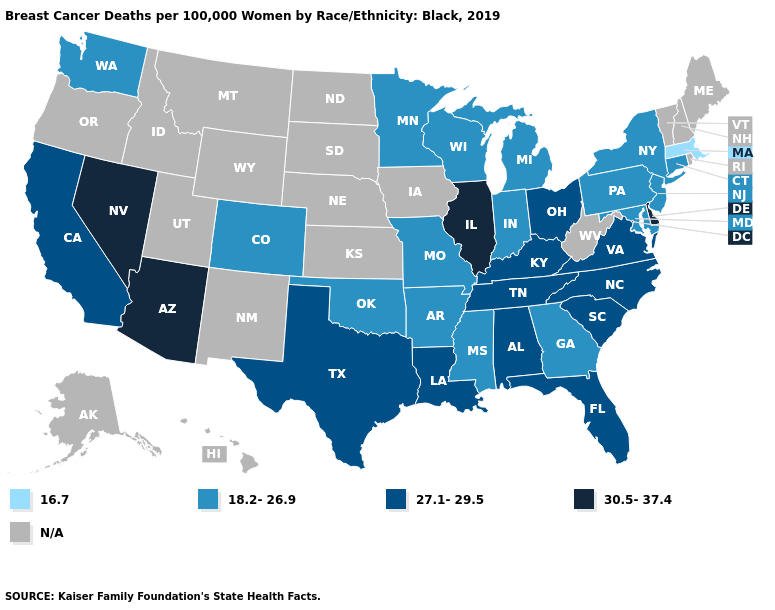Name the states that have a value in the range 18.2-26.9?
Answer briefly. Arkansas, Colorado, Connecticut, Georgia, Indiana, Maryland, Michigan, Minnesota, Mississippi, Missouri, New Jersey, New York, Oklahoma, Pennsylvania, Washington, Wisconsin. Which states have the lowest value in the USA?
Concise answer only. Massachusetts. Does Arizona have the lowest value in the West?
Be succinct. No. Is the legend a continuous bar?
Concise answer only. No. Name the states that have a value in the range N/A?
Write a very short answer. Alaska, Hawaii, Idaho, Iowa, Kansas, Maine, Montana, Nebraska, New Hampshire, New Mexico, North Dakota, Oregon, Rhode Island, South Dakota, Utah, Vermont, West Virginia, Wyoming. What is the lowest value in states that border South Carolina?
Give a very brief answer. 18.2-26.9. Does the map have missing data?
Keep it brief. Yes. Name the states that have a value in the range 27.1-29.5?
Concise answer only. Alabama, California, Florida, Kentucky, Louisiana, North Carolina, Ohio, South Carolina, Tennessee, Texas, Virginia. What is the highest value in the South ?
Quick response, please. 30.5-37.4. What is the value of Alaska?
Answer briefly. N/A. What is the highest value in states that border Virginia?
Concise answer only. 27.1-29.5. What is the value of Rhode Island?
Write a very short answer. N/A. Which states have the lowest value in the West?
Write a very short answer. Colorado, Washington. 